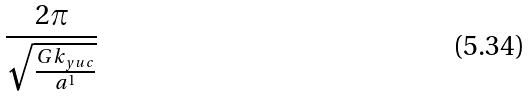Convert formula to latex. <formula><loc_0><loc_0><loc_500><loc_500>\frac { 2 \pi } { \sqrt { \frac { G k _ { y u c } } { a ^ { 1 } } } }</formula> 